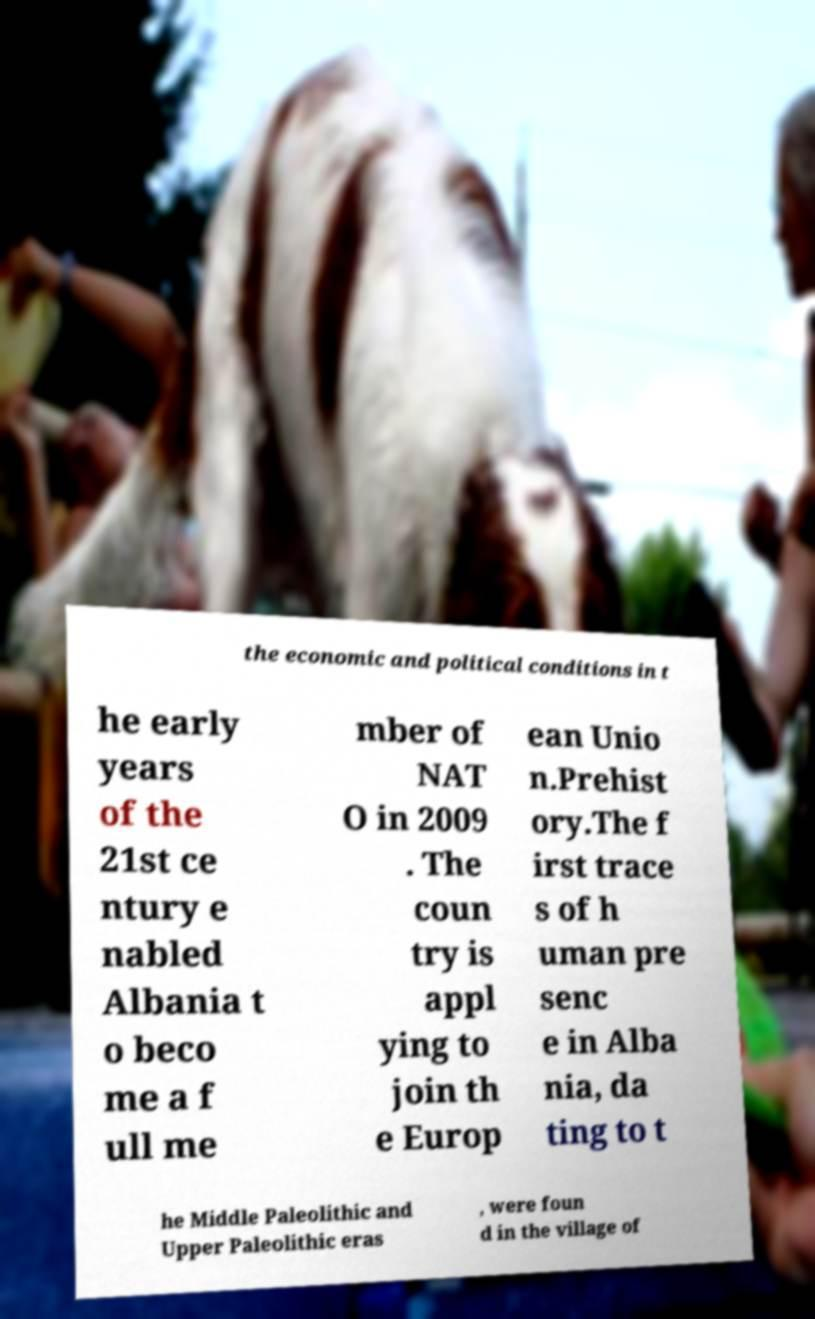Can you read and provide the text displayed in the image?This photo seems to have some interesting text. Can you extract and type it out for me? the economic and political conditions in t he early years of the 21st ce ntury e nabled Albania t o beco me a f ull me mber of NAT O in 2009 . The coun try is appl ying to join th e Europ ean Unio n.Prehist ory.The f irst trace s of h uman pre senc e in Alba nia, da ting to t he Middle Paleolithic and Upper Paleolithic eras , were foun d in the village of 